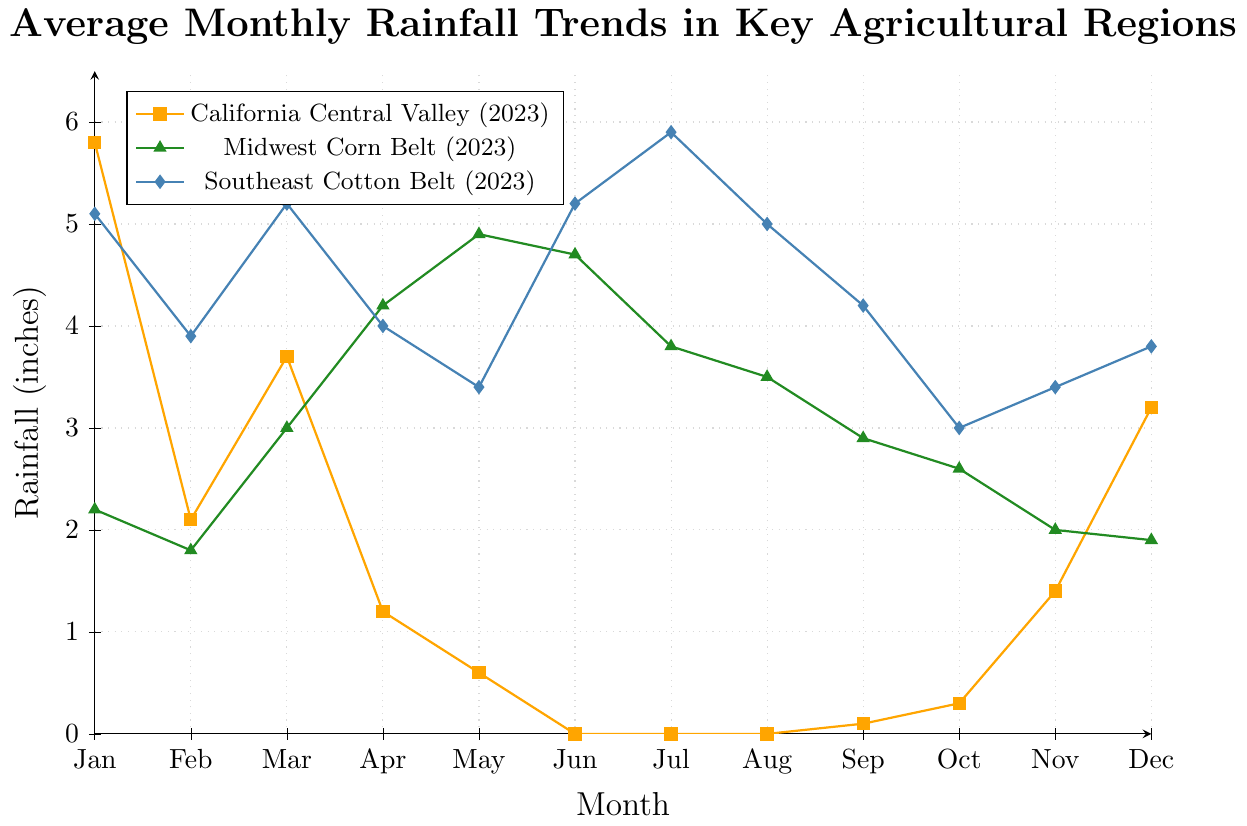Which region had the highest rainfall in January 2023? The figure shows the rainfall trends for 2023. By comparing the January data points, we see that the Southeast Cotton Belt with 5.1 inches of rainfall has the highest value.
Answer: Southeast Cotton Belt Which region had the lowest average rainfall over the entire year in 2023? To find the average rainfall, add the monthly rainfall values for each region and divide by 12. Summing these up:
- California Central Valley: 5.8 + 2.1 + 3.7 + 1.2 + 0.6 + 0 + 0 + 0 + 0.1 + 0.3 + 1.4 + 3.2 = 18.4, average = 18.4/12 ≈ 1.53
- Midwest Corn Belt: 2.2 + 1.8 + 3 + 4.2 + 4.9 + 4.7 + 3.8 + 3.5 + 2.9 + 2.6 + 2 + 1.9 = 37.5, average = 37.5/12 ≈ 3.125
- Southeast Cotton Belt: 5.1 + 3.9 + 5.2 + 4 + 3.4 + 5.2 + 5.9 + 5 + 4.2 + 3 + 3.4 + 3.8 = 51.1, average = 51.1/12 ≈ 4.26
Thus, California Central Valley has the lowest average.
Answer: California Central Valley In which month did the Midwest Corn Belt receive the most rainfall in 2023? By observing the figure, the peak rainfall for the Midwest Corn Belt curve occurs in May with 4.9 inches.
Answer: May How many months had zero rainfall in the California Central Valley in 2023? By analyzing the California Central Valley plot for 2023, the months with zero rainfall are June, July, and August. This makes 3 months in total.
Answer: 3 Compare the rainfall in March 2023 between Midwest Corn Belt and Southeast Cotton Belt. Which had more, and by how much? From the figure, the rainfall in March for the Midwest Corn Belt is 3.0 inches and for the Southeast Cotton Belt is 5.2 inches. The difference is 5.2 - 3.0 = 2.2 inches more for the Southeast Cotton Belt.
Answer: Southeast Cotton Belt, 2.2 inches How did the rainfall in California Central Valley vary between February and March 2023? In February 2023, California Central Valley received 2.1 inches of rainfall, and in March 2023 it received 3.7 inches. The difference is 3.7 - 2.1 = 1.6 inches more in March.
Answer: Increased by 1.6 inches What is the average rainfall in the Southeast Cotton Belt from June to August in 2023? Adding the rainfall values from June to August: 5.2 + 5.9 + 5.0 = 16.1 inches. Dividing by 3 months, we get an average of 16.1/3 ≈ 5.37 inches.
Answer: 5.37 inches Which region had the highest rainfall in the month of April 2023? By inspecting the April rainfall values from the figure, we see 1.2 inches in California Central Valley, 4.2 inches in the Midwest Corn Belt, and 4.0 inches in the Southeast Cotton Belt. Thus, Midwest Corn Belt has the highest with 4.2 inches.
Answer: Midwest Corn Belt 